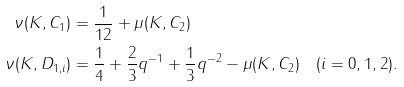<formula> <loc_0><loc_0><loc_500><loc_500>\nu ( K , C _ { 1 } ) & = \frac { 1 } { 1 2 } + \mu ( K , C _ { 2 } ) \\ \nu ( K , D _ { 1 , i } ) & = \frac { 1 } { 4 } + \frac { 2 } { 3 } q ^ { - 1 } + \frac { 1 } { 3 } q ^ { - 2 } - \mu ( K , C _ { 2 } ) \quad ( i = 0 , 1 , 2 ) .</formula> 